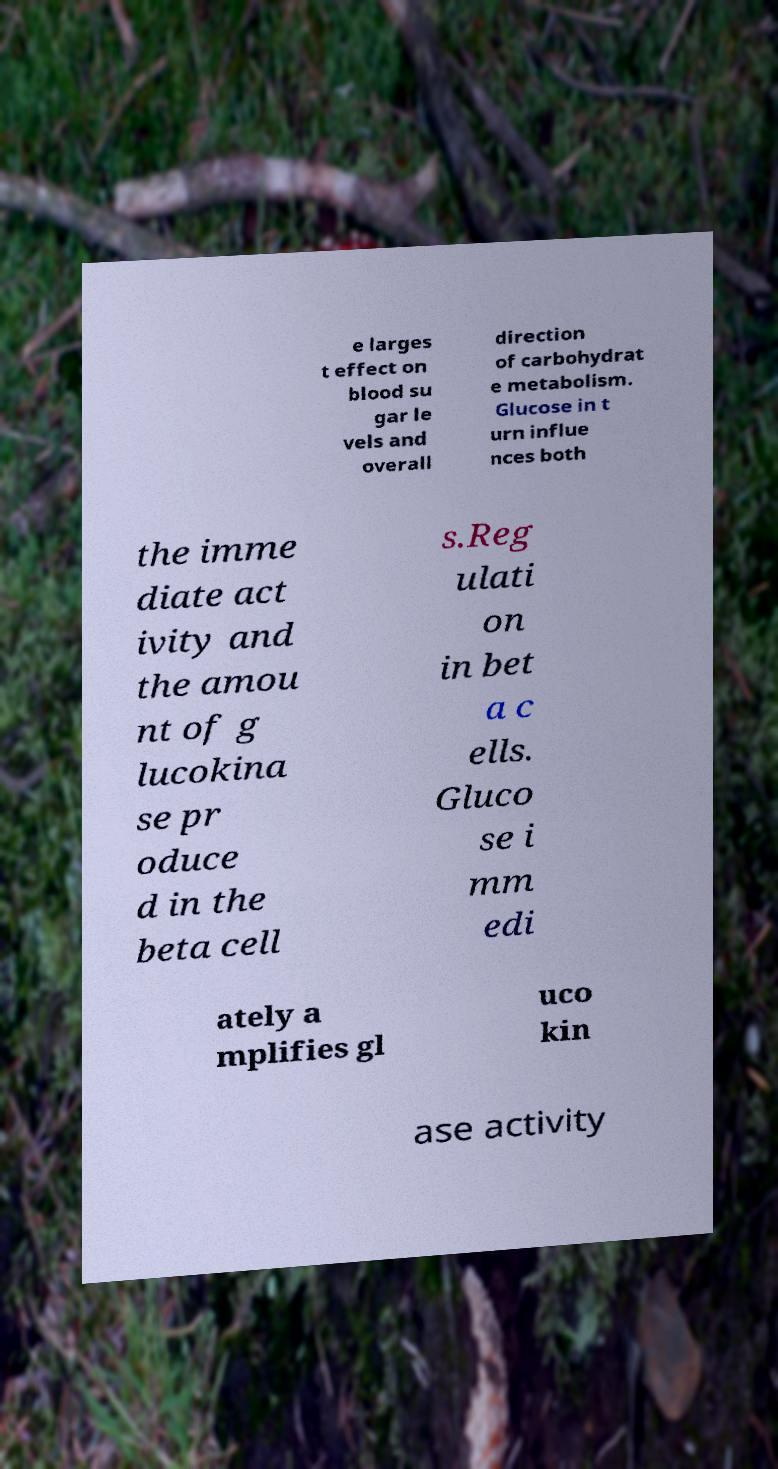I need the written content from this picture converted into text. Can you do that? e larges t effect on blood su gar le vels and overall direction of carbohydrat e metabolism. Glucose in t urn influe nces both the imme diate act ivity and the amou nt of g lucokina se pr oduce d in the beta cell s.Reg ulati on in bet a c ells. Gluco se i mm edi ately a mplifies gl uco kin ase activity 